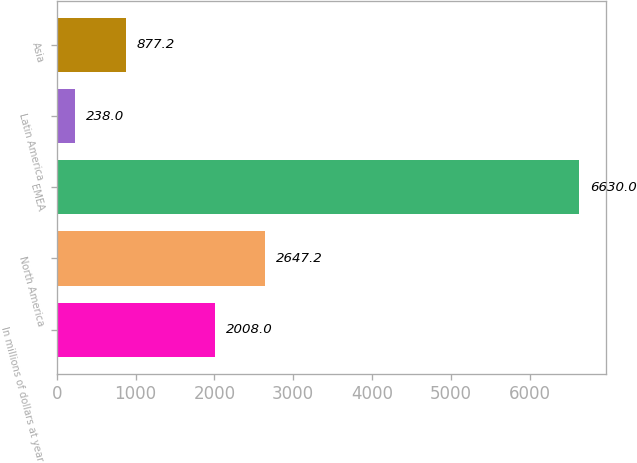Convert chart. <chart><loc_0><loc_0><loc_500><loc_500><bar_chart><fcel>In millions of dollars at year<fcel>North America<fcel>EMEA<fcel>Latin America<fcel>Asia<nl><fcel>2008<fcel>2647.2<fcel>6630<fcel>238<fcel>877.2<nl></chart> 